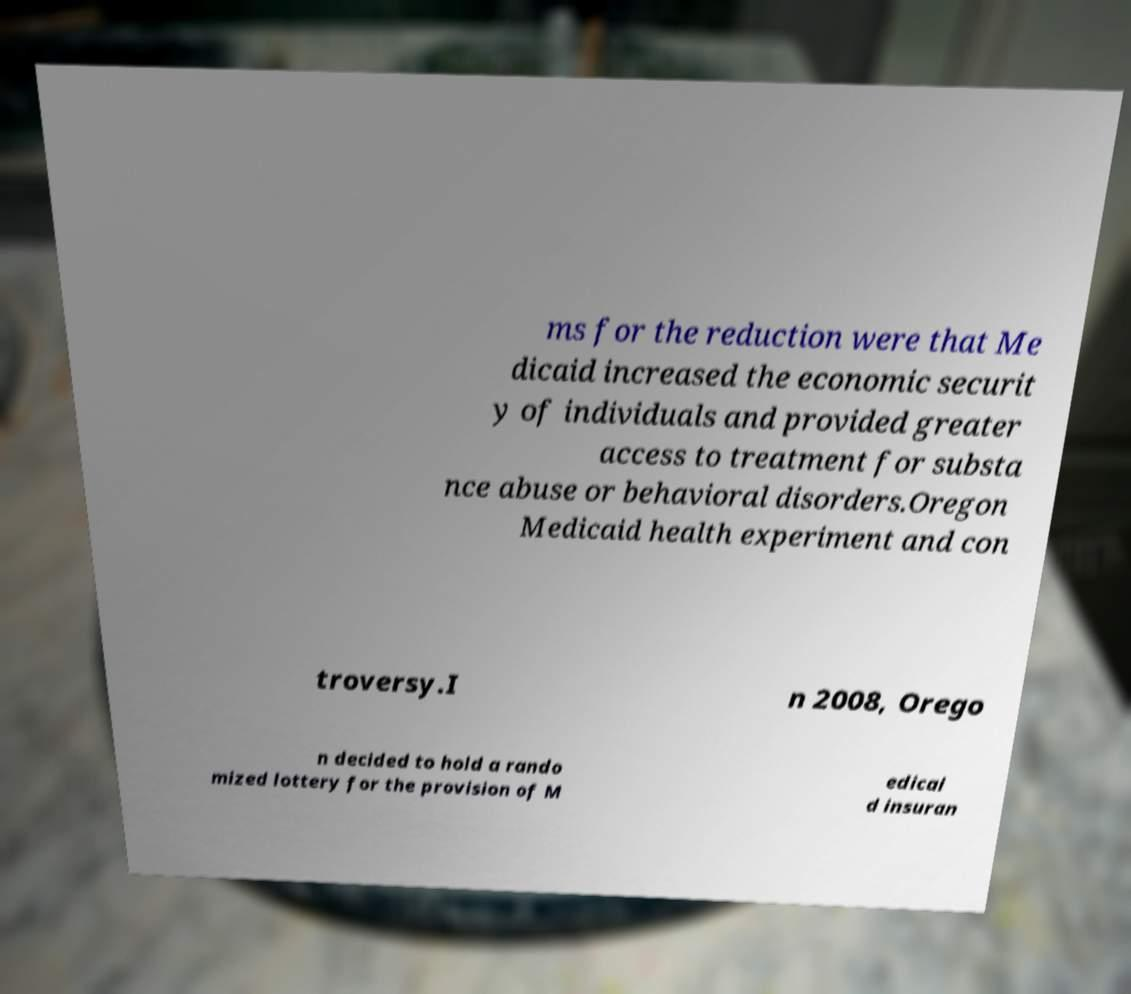Could you extract and type out the text from this image? ms for the reduction were that Me dicaid increased the economic securit y of individuals and provided greater access to treatment for substa nce abuse or behavioral disorders.Oregon Medicaid health experiment and con troversy.I n 2008, Orego n decided to hold a rando mized lottery for the provision of M edicai d insuran 